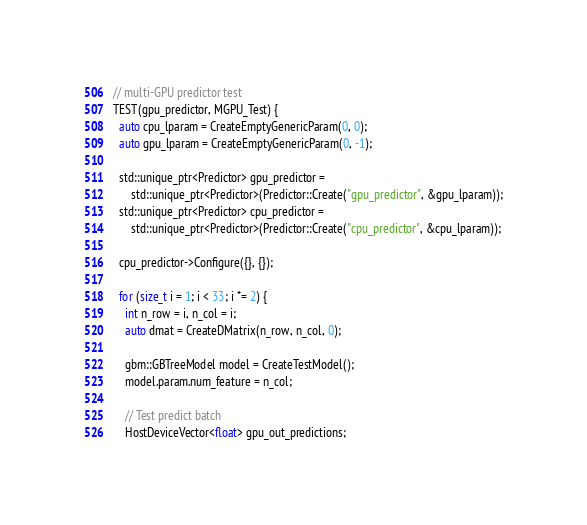<code> <loc_0><loc_0><loc_500><loc_500><_Cuda_>
// multi-GPU predictor test
TEST(gpu_predictor, MGPU_Test) {
  auto cpu_lparam = CreateEmptyGenericParam(0, 0);
  auto gpu_lparam = CreateEmptyGenericParam(0, -1);

  std::unique_ptr<Predictor> gpu_predictor =
      std::unique_ptr<Predictor>(Predictor::Create("gpu_predictor", &gpu_lparam));
  std::unique_ptr<Predictor> cpu_predictor =
      std::unique_ptr<Predictor>(Predictor::Create("cpu_predictor", &cpu_lparam));

  cpu_predictor->Configure({}, {});

  for (size_t i = 1; i < 33; i *= 2) {
    int n_row = i, n_col = i;
    auto dmat = CreateDMatrix(n_row, n_col, 0);

    gbm::GBTreeModel model = CreateTestModel();
    model.param.num_feature = n_col;

    // Test predict batch
    HostDeviceVector<float> gpu_out_predictions;</code> 